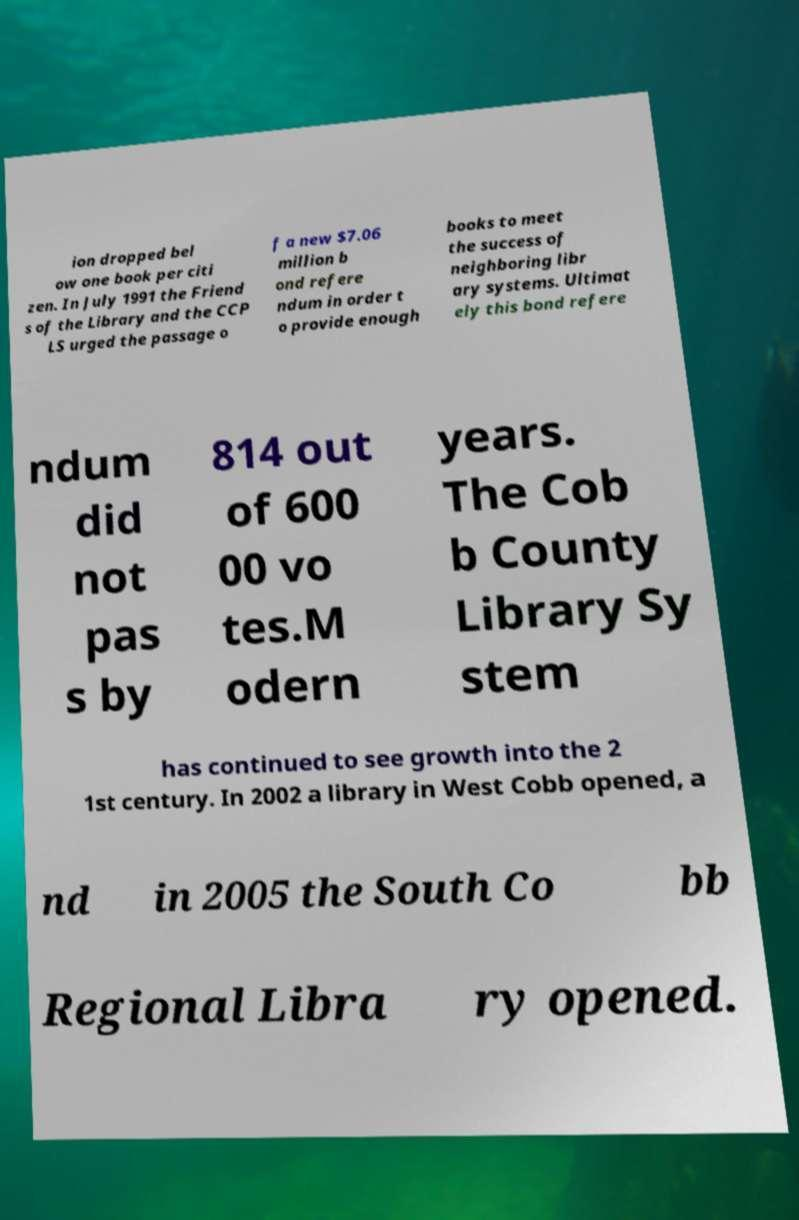There's text embedded in this image that I need extracted. Can you transcribe it verbatim? ion dropped bel ow one book per citi zen. In July 1991 the Friend s of the Library and the CCP LS urged the passage o f a new $7.06 million b ond refere ndum in order t o provide enough books to meet the success of neighboring libr ary systems. Ultimat ely this bond refere ndum did not pas s by 814 out of 600 00 vo tes.M odern years. The Cob b County Library Sy stem has continued to see growth into the 2 1st century. In 2002 a library in West Cobb opened, a nd in 2005 the South Co bb Regional Libra ry opened. 